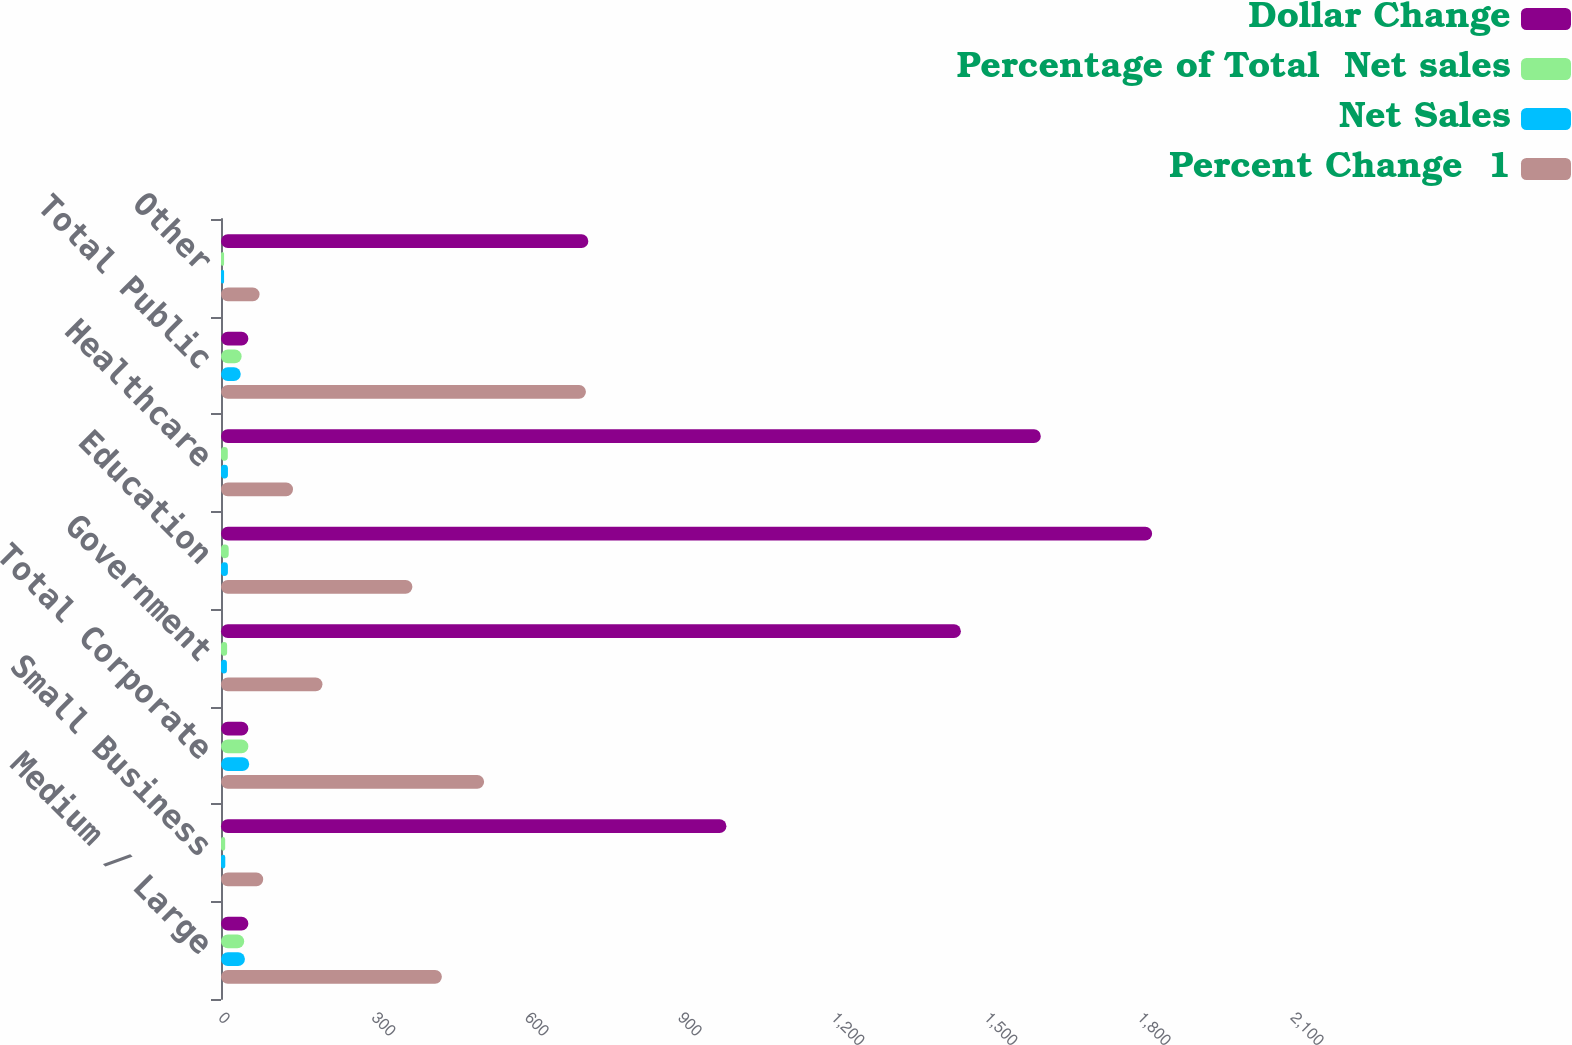Convert chart. <chart><loc_0><loc_0><loc_500><loc_500><stacked_bar_chart><ecel><fcel>Medium / Large<fcel>Small Business<fcel>Total Corporate<fcel>Government<fcel>Education<fcel>Healthcare<fcel>Total Public<fcel>Other<nl><fcel>Dollar Change<fcel>53.6<fcel>990.1<fcel>53.6<fcel>1449.4<fcel>1824<fcel>1606<fcel>53.6<fcel>719.6<nl><fcel>Percentage of Total  Net sales<fcel>45.4<fcel>8.2<fcel>53.6<fcel>12<fcel>15.1<fcel>13.3<fcel>40.4<fcel>6<nl><fcel>Net Sales<fcel>46.9<fcel>8.4<fcel>55.3<fcel>11.6<fcel>13.5<fcel>13.6<fcel>38.7<fcel>6<nl><fcel>Percent Change  1<fcel>432.7<fcel>82.7<fcel>515.4<fcel>198.8<fcel>375<fcel>141.1<fcel>714.9<fcel>75.6<nl></chart> 